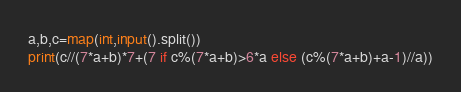Convert code to text. <code><loc_0><loc_0><loc_500><loc_500><_Python_>a,b,c=map(int,input().split())
print(c//(7*a+b)*7+(7 if c%(7*a+b)>6*a else (c%(7*a+b)+a-1)//a))
</code> 